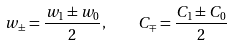<formula> <loc_0><loc_0><loc_500><loc_500>w _ { \pm } = \frac { w _ { 1 } \pm w _ { 0 } } { 2 } , \quad C _ { \mp } = \frac { C _ { 1 } \pm C _ { 0 } } { 2 }</formula> 